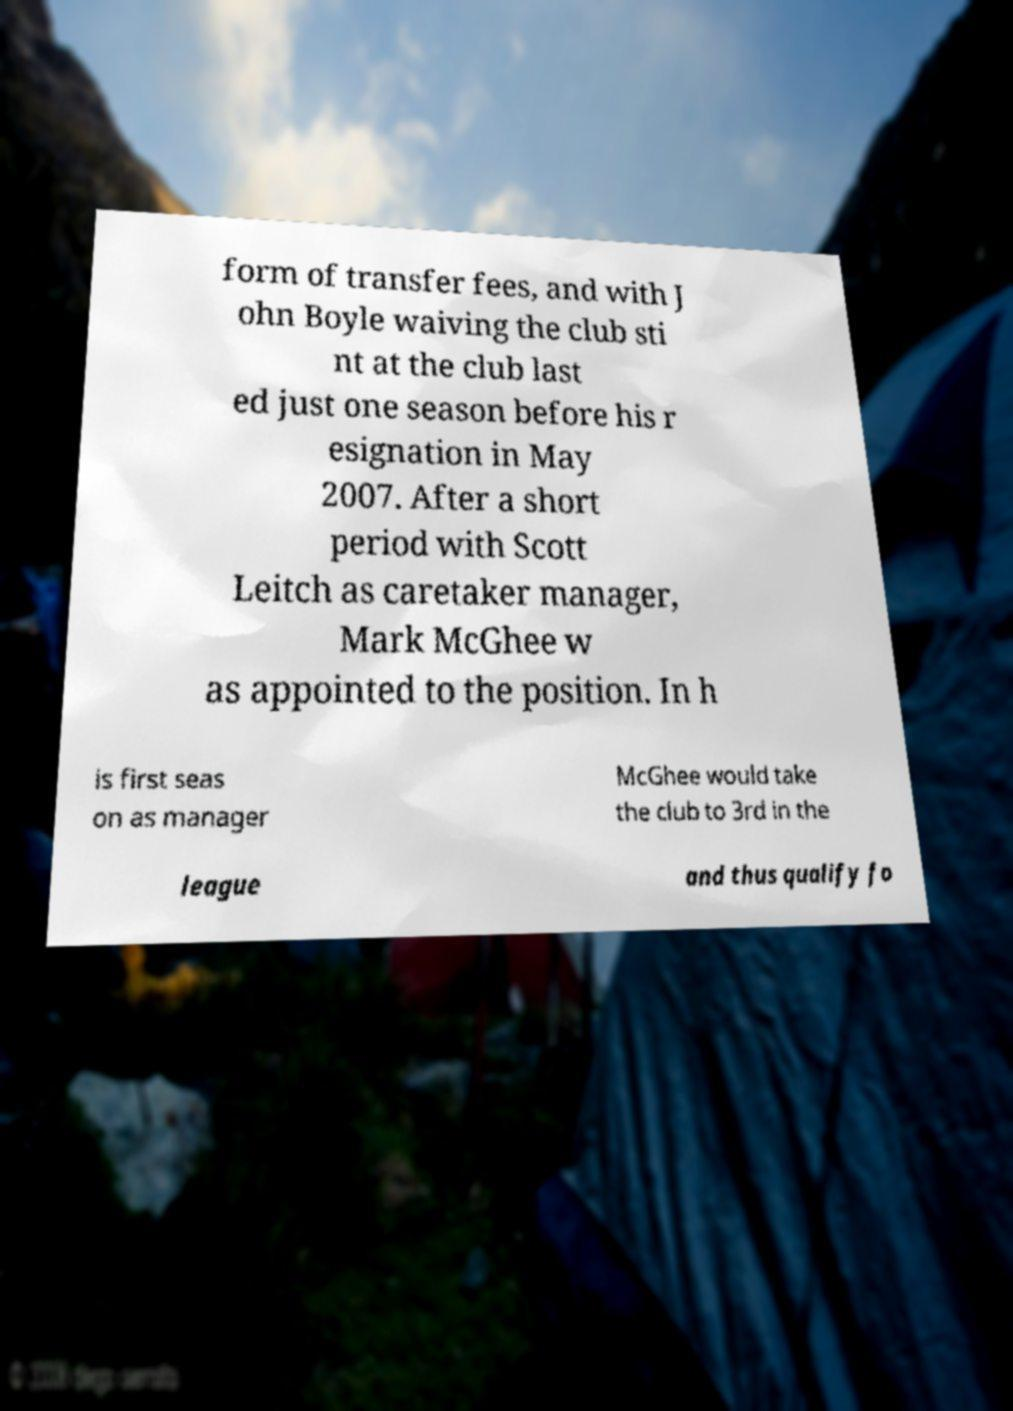There's text embedded in this image that I need extracted. Can you transcribe it verbatim? form of transfer fees, and with J ohn Boyle waiving the club sti nt at the club last ed just one season before his r esignation in May 2007. After a short period with Scott Leitch as caretaker manager, Mark McGhee w as appointed to the position. In h is first seas on as manager McGhee would take the club to 3rd in the league and thus qualify fo 